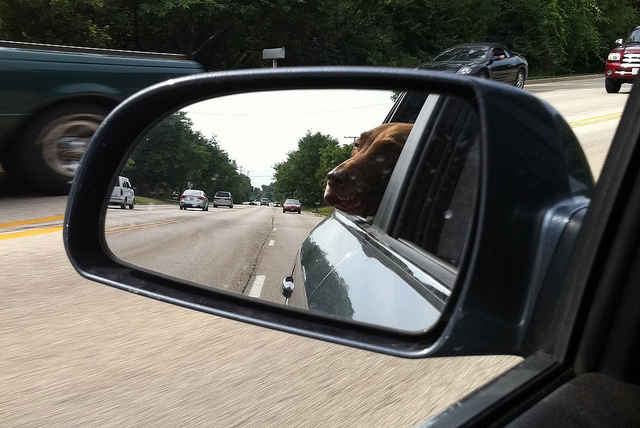<image>What is the breed of dog in the vehicle? I am not sure about the breed of the dog in the vehicle. It can be a hound, lab, retriever mix, chocolate lab, irish setter, or a terrier. What is the breed of dog in the vehicle? I am not sure the breed of the dog in the vehicle. It can be 'hound', 'lab', 'labrador', 'retriever mix', 'chocolate lab', 'irish setter' or 'terrier'. 